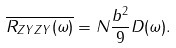<formula> <loc_0><loc_0><loc_500><loc_500>\overline { R _ { Z Y Z Y } ( \omega ) } = N \frac { b ^ { 2 } } { 9 } D ( \omega ) .</formula> 